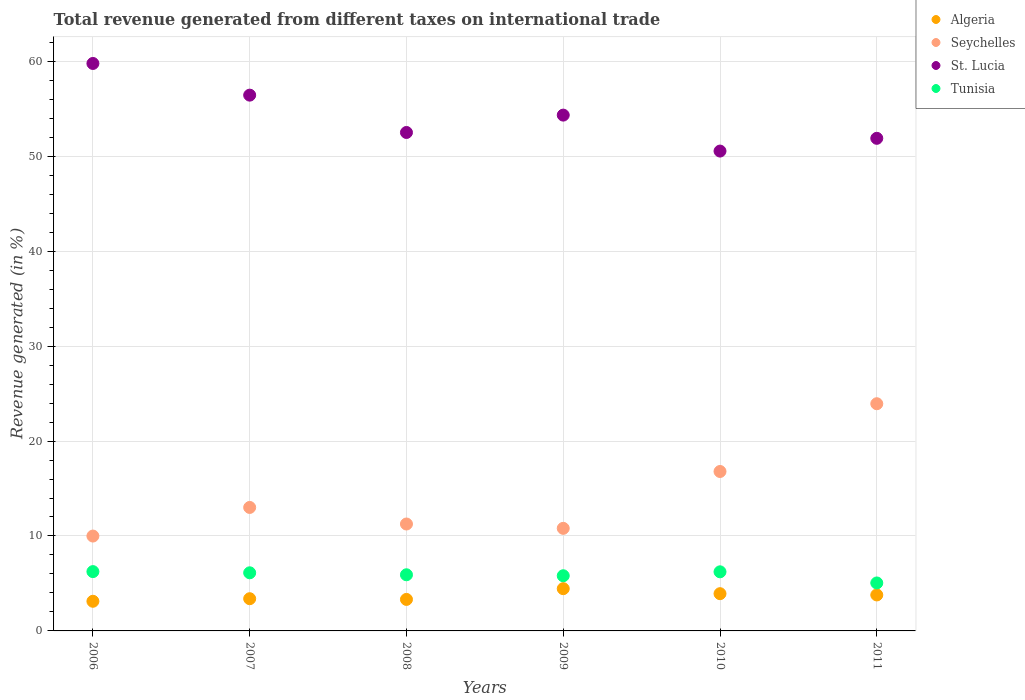Is the number of dotlines equal to the number of legend labels?
Your answer should be very brief. Yes. What is the total revenue generated in Tunisia in 2011?
Make the answer very short. 5.05. Across all years, what is the maximum total revenue generated in Tunisia?
Make the answer very short. 6.25. Across all years, what is the minimum total revenue generated in Tunisia?
Give a very brief answer. 5.05. In which year was the total revenue generated in Seychelles minimum?
Your answer should be compact. 2006. What is the total total revenue generated in St. Lucia in the graph?
Ensure brevity in your answer.  325.46. What is the difference between the total revenue generated in Seychelles in 2007 and that in 2011?
Make the answer very short. -10.92. What is the difference between the total revenue generated in Seychelles in 2007 and the total revenue generated in Algeria in 2010?
Your answer should be very brief. 9.08. What is the average total revenue generated in Seychelles per year?
Keep it short and to the point. 14.3. In the year 2006, what is the difference between the total revenue generated in Tunisia and total revenue generated in St. Lucia?
Your response must be concise. -53.52. In how many years, is the total revenue generated in St. Lucia greater than 36 %?
Offer a very short reply. 6. What is the ratio of the total revenue generated in St. Lucia in 2009 to that in 2011?
Your answer should be very brief. 1.05. Is the total revenue generated in Seychelles in 2010 less than that in 2011?
Provide a succinct answer. Yes. Is the difference between the total revenue generated in Tunisia in 2008 and 2011 greater than the difference between the total revenue generated in St. Lucia in 2008 and 2011?
Your answer should be compact. Yes. What is the difference between the highest and the second highest total revenue generated in Seychelles?
Your answer should be compact. 7.14. What is the difference between the highest and the lowest total revenue generated in Tunisia?
Ensure brevity in your answer.  1.2. Is it the case that in every year, the sum of the total revenue generated in St. Lucia and total revenue generated in Tunisia  is greater than the sum of total revenue generated in Algeria and total revenue generated in Seychelles?
Give a very brief answer. No. Is it the case that in every year, the sum of the total revenue generated in St. Lucia and total revenue generated in Seychelles  is greater than the total revenue generated in Algeria?
Your answer should be compact. Yes. Is the total revenue generated in Algeria strictly greater than the total revenue generated in Seychelles over the years?
Provide a succinct answer. No. Is the total revenue generated in St. Lucia strictly less than the total revenue generated in Tunisia over the years?
Keep it short and to the point. No. How many dotlines are there?
Ensure brevity in your answer.  4. How many years are there in the graph?
Offer a terse response. 6. What is the difference between two consecutive major ticks on the Y-axis?
Provide a short and direct response. 10. Where does the legend appear in the graph?
Your answer should be compact. Top right. How many legend labels are there?
Offer a very short reply. 4. How are the legend labels stacked?
Your answer should be compact. Vertical. What is the title of the graph?
Keep it short and to the point. Total revenue generated from different taxes on international trade. What is the label or title of the Y-axis?
Keep it short and to the point. Revenue generated (in %). What is the Revenue generated (in %) of Algeria in 2006?
Provide a succinct answer. 3.12. What is the Revenue generated (in %) of Seychelles in 2006?
Offer a terse response. 9.99. What is the Revenue generated (in %) of St. Lucia in 2006?
Give a very brief answer. 59.77. What is the Revenue generated (in %) of Tunisia in 2006?
Make the answer very short. 6.25. What is the Revenue generated (in %) of Algeria in 2007?
Your answer should be very brief. 3.39. What is the Revenue generated (in %) of Seychelles in 2007?
Give a very brief answer. 13.01. What is the Revenue generated (in %) in St. Lucia in 2007?
Give a very brief answer. 56.43. What is the Revenue generated (in %) of Tunisia in 2007?
Your answer should be very brief. 6.12. What is the Revenue generated (in %) in Algeria in 2008?
Your answer should be very brief. 3.32. What is the Revenue generated (in %) of Seychelles in 2008?
Your response must be concise. 11.26. What is the Revenue generated (in %) of St. Lucia in 2008?
Make the answer very short. 52.5. What is the Revenue generated (in %) in Tunisia in 2008?
Provide a short and direct response. 5.91. What is the Revenue generated (in %) of Algeria in 2009?
Give a very brief answer. 4.45. What is the Revenue generated (in %) of Seychelles in 2009?
Offer a terse response. 10.8. What is the Revenue generated (in %) in St. Lucia in 2009?
Make the answer very short. 54.33. What is the Revenue generated (in %) in Tunisia in 2009?
Offer a very short reply. 5.81. What is the Revenue generated (in %) of Algeria in 2010?
Your answer should be very brief. 3.92. What is the Revenue generated (in %) in Seychelles in 2010?
Offer a very short reply. 16.79. What is the Revenue generated (in %) in St. Lucia in 2010?
Give a very brief answer. 50.54. What is the Revenue generated (in %) of Tunisia in 2010?
Provide a short and direct response. 6.23. What is the Revenue generated (in %) of Algeria in 2011?
Your response must be concise. 3.79. What is the Revenue generated (in %) of Seychelles in 2011?
Provide a succinct answer. 23.93. What is the Revenue generated (in %) of St. Lucia in 2011?
Provide a short and direct response. 51.89. What is the Revenue generated (in %) in Tunisia in 2011?
Provide a succinct answer. 5.05. Across all years, what is the maximum Revenue generated (in %) of Algeria?
Make the answer very short. 4.45. Across all years, what is the maximum Revenue generated (in %) of Seychelles?
Make the answer very short. 23.93. Across all years, what is the maximum Revenue generated (in %) of St. Lucia?
Provide a succinct answer. 59.77. Across all years, what is the maximum Revenue generated (in %) of Tunisia?
Provide a succinct answer. 6.25. Across all years, what is the minimum Revenue generated (in %) of Algeria?
Offer a very short reply. 3.12. Across all years, what is the minimum Revenue generated (in %) in Seychelles?
Your answer should be compact. 9.99. Across all years, what is the minimum Revenue generated (in %) in St. Lucia?
Keep it short and to the point. 50.54. Across all years, what is the minimum Revenue generated (in %) of Tunisia?
Provide a short and direct response. 5.05. What is the total Revenue generated (in %) of Algeria in the graph?
Keep it short and to the point. 22. What is the total Revenue generated (in %) in Seychelles in the graph?
Your answer should be very brief. 85.79. What is the total Revenue generated (in %) of St. Lucia in the graph?
Your response must be concise. 325.46. What is the total Revenue generated (in %) of Tunisia in the graph?
Your response must be concise. 35.37. What is the difference between the Revenue generated (in %) in Algeria in 2006 and that in 2007?
Keep it short and to the point. -0.27. What is the difference between the Revenue generated (in %) of Seychelles in 2006 and that in 2007?
Make the answer very short. -3.01. What is the difference between the Revenue generated (in %) of St. Lucia in 2006 and that in 2007?
Your answer should be very brief. 3.34. What is the difference between the Revenue generated (in %) of Tunisia in 2006 and that in 2007?
Ensure brevity in your answer.  0.13. What is the difference between the Revenue generated (in %) of Algeria in 2006 and that in 2008?
Provide a succinct answer. -0.2. What is the difference between the Revenue generated (in %) of Seychelles in 2006 and that in 2008?
Offer a terse response. -1.27. What is the difference between the Revenue generated (in %) in St. Lucia in 2006 and that in 2008?
Your answer should be compact. 7.27. What is the difference between the Revenue generated (in %) of Tunisia in 2006 and that in 2008?
Keep it short and to the point. 0.33. What is the difference between the Revenue generated (in %) in Algeria in 2006 and that in 2009?
Your answer should be very brief. -1.33. What is the difference between the Revenue generated (in %) in Seychelles in 2006 and that in 2009?
Your response must be concise. -0.81. What is the difference between the Revenue generated (in %) in St. Lucia in 2006 and that in 2009?
Ensure brevity in your answer.  5.44. What is the difference between the Revenue generated (in %) of Tunisia in 2006 and that in 2009?
Your answer should be compact. 0.44. What is the difference between the Revenue generated (in %) in Algeria in 2006 and that in 2010?
Give a very brief answer. -0.8. What is the difference between the Revenue generated (in %) in Seychelles in 2006 and that in 2010?
Offer a very short reply. -6.8. What is the difference between the Revenue generated (in %) in St. Lucia in 2006 and that in 2010?
Ensure brevity in your answer.  9.23. What is the difference between the Revenue generated (in %) of Tunisia in 2006 and that in 2010?
Provide a succinct answer. 0.02. What is the difference between the Revenue generated (in %) in Algeria in 2006 and that in 2011?
Your answer should be compact. -0.67. What is the difference between the Revenue generated (in %) in Seychelles in 2006 and that in 2011?
Ensure brevity in your answer.  -13.94. What is the difference between the Revenue generated (in %) of St. Lucia in 2006 and that in 2011?
Provide a succinct answer. 7.88. What is the difference between the Revenue generated (in %) of Tunisia in 2006 and that in 2011?
Provide a succinct answer. 1.2. What is the difference between the Revenue generated (in %) of Algeria in 2007 and that in 2008?
Offer a very short reply. 0.07. What is the difference between the Revenue generated (in %) of Seychelles in 2007 and that in 2008?
Keep it short and to the point. 1.74. What is the difference between the Revenue generated (in %) in St. Lucia in 2007 and that in 2008?
Keep it short and to the point. 3.93. What is the difference between the Revenue generated (in %) in Tunisia in 2007 and that in 2008?
Offer a very short reply. 0.21. What is the difference between the Revenue generated (in %) of Algeria in 2007 and that in 2009?
Your answer should be compact. -1.06. What is the difference between the Revenue generated (in %) in Seychelles in 2007 and that in 2009?
Your response must be concise. 2.2. What is the difference between the Revenue generated (in %) of St. Lucia in 2007 and that in 2009?
Your answer should be very brief. 2.1. What is the difference between the Revenue generated (in %) in Tunisia in 2007 and that in 2009?
Offer a terse response. 0.31. What is the difference between the Revenue generated (in %) of Algeria in 2007 and that in 2010?
Offer a terse response. -0.53. What is the difference between the Revenue generated (in %) of Seychelles in 2007 and that in 2010?
Offer a very short reply. -3.79. What is the difference between the Revenue generated (in %) of St. Lucia in 2007 and that in 2010?
Ensure brevity in your answer.  5.89. What is the difference between the Revenue generated (in %) in Tunisia in 2007 and that in 2010?
Make the answer very short. -0.1. What is the difference between the Revenue generated (in %) in Algeria in 2007 and that in 2011?
Provide a succinct answer. -0.4. What is the difference between the Revenue generated (in %) of Seychelles in 2007 and that in 2011?
Ensure brevity in your answer.  -10.92. What is the difference between the Revenue generated (in %) of St. Lucia in 2007 and that in 2011?
Offer a terse response. 4.55. What is the difference between the Revenue generated (in %) of Tunisia in 2007 and that in 2011?
Offer a very short reply. 1.07. What is the difference between the Revenue generated (in %) of Algeria in 2008 and that in 2009?
Keep it short and to the point. -1.13. What is the difference between the Revenue generated (in %) in Seychelles in 2008 and that in 2009?
Give a very brief answer. 0.46. What is the difference between the Revenue generated (in %) of St. Lucia in 2008 and that in 2009?
Offer a very short reply. -1.83. What is the difference between the Revenue generated (in %) in Tunisia in 2008 and that in 2009?
Keep it short and to the point. 0.1. What is the difference between the Revenue generated (in %) in Algeria in 2008 and that in 2010?
Provide a succinct answer. -0.6. What is the difference between the Revenue generated (in %) in Seychelles in 2008 and that in 2010?
Ensure brevity in your answer.  -5.53. What is the difference between the Revenue generated (in %) of St. Lucia in 2008 and that in 2010?
Offer a very short reply. 1.96. What is the difference between the Revenue generated (in %) in Tunisia in 2008 and that in 2010?
Ensure brevity in your answer.  -0.31. What is the difference between the Revenue generated (in %) of Algeria in 2008 and that in 2011?
Provide a short and direct response. -0.47. What is the difference between the Revenue generated (in %) in Seychelles in 2008 and that in 2011?
Give a very brief answer. -12.67. What is the difference between the Revenue generated (in %) of St. Lucia in 2008 and that in 2011?
Provide a succinct answer. 0.61. What is the difference between the Revenue generated (in %) in Tunisia in 2008 and that in 2011?
Your response must be concise. 0.86. What is the difference between the Revenue generated (in %) of Algeria in 2009 and that in 2010?
Give a very brief answer. 0.53. What is the difference between the Revenue generated (in %) of Seychelles in 2009 and that in 2010?
Offer a terse response. -5.99. What is the difference between the Revenue generated (in %) of St. Lucia in 2009 and that in 2010?
Ensure brevity in your answer.  3.79. What is the difference between the Revenue generated (in %) of Tunisia in 2009 and that in 2010?
Give a very brief answer. -0.41. What is the difference between the Revenue generated (in %) of Algeria in 2009 and that in 2011?
Your answer should be very brief. 0.66. What is the difference between the Revenue generated (in %) of Seychelles in 2009 and that in 2011?
Make the answer very short. -13.13. What is the difference between the Revenue generated (in %) in St. Lucia in 2009 and that in 2011?
Your response must be concise. 2.44. What is the difference between the Revenue generated (in %) of Tunisia in 2009 and that in 2011?
Offer a terse response. 0.76. What is the difference between the Revenue generated (in %) of Algeria in 2010 and that in 2011?
Offer a very short reply. 0.13. What is the difference between the Revenue generated (in %) of Seychelles in 2010 and that in 2011?
Ensure brevity in your answer.  -7.14. What is the difference between the Revenue generated (in %) of St. Lucia in 2010 and that in 2011?
Keep it short and to the point. -1.34. What is the difference between the Revenue generated (in %) in Tunisia in 2010 and that in 2011?
Your answer should be very brief. 1.17. What is the difference between the Revenue generated (in %) in Algeria in 2006 and the Revenue generated (in %) in Seychelles in 2007?
Your answer should be very brief. -9.88. What is the difference between the Revenue generated (in %) of Algeria in 2006 and the Revenue generated (in %) of St. Lucia in 2007?
Ensure brevity in your answer.  -53.31. What is the difference between the Revenue generated (in %) in Algeria in 2006 and the Revenue generated (in %) in Tunisia in 2007?
Your response must be concise. -3. What is the difference between the Revenue generated (in %) of Seychelles in 2006 and the Revenue generated (in %) of St. Lucia in 2007?
Offer a very short reply. -46.44. What is the difference between the Revenue generated (in %) in Seychelles in 2006 and the Revenue generated (in %) in Tunisia in 2007?
Provide a succinct answer. 3.87. What is the difference between the Revenue generated (in %) in St. Lucia in 2006 and the Revenue generated (in %) in Tunisia in 2007?
Ensure brevity in your answer.  53.65. What is the difference between the Revenue generated (in %) of Algeria in 2006 and the Revenue generated (in %) of Seychelles in 2008?
Your answer should be very brief. -8.14. What is the difference between the Revenue generated (in %) in Algeria in 2006 and the Revenue generated (in %) in St. Lucia in 2008?
Keep it short and to the point. -49.38. What is the difference between the Revenue generated (in %) of Algeria in 2006 and the Revenue generated (in %) of Tunisia in 2008?
Make the answer very short. -2.79. What is the difference between the Revenue generated (in %) of Seychelles in 2006 and the Revenue generated (in %) of St. Lucia in 2008?
Provide a succinct answer. -42.51. What is the difference between the Revenue generated (in %) in Seychelles in 2006 and the Revenue generated (in %) in Tunisia in 2008?
Ensure brevity in your answer.  4.08. What is the difference between the Revenue generated (in %) of St. Lucia in 2006 and the Revenue generated (in %) of Tunisia in 2008?
Offer a very short reply. 53.86. What is the difference between the Revenue generated (in %) of Algeria in 2006 and the Revenue generated (in %) of Seychelles in 2009?
Your answer should be compact. -7.68. What is the difference between the Revenue generated (in %) of Algeria in 2006 and the Revenue generated (in %) of St. Lucia in 2009?
Offer a terse response. -51.21. What is the difference between the Revenue generated (in %) in Algeria in 2006 and the Revenue generated (in %) in Tunisia in 2009?
Provide a short and direct response. -2.69. What is the difference between the Revenue generated (in %) in Seychelles in 2006 and the Revenue generated (in %) in St. Lucia in 2009?
Your response must be concise. -44.34. What is the difference between the Revenue generated (in %) of Seychelles in 2006 and the Revenue generated (in %) of Tunisia in 2009?
Give a very brief answer. 4.18. What is the difference between the Revenue generated (in %) in St. Lucia in 2006 and the Revenue generated (in %) in Tunisia in 2009?
Your answer should be compact. 53.96. What is the difference between the Revenue generated (in %) in Algeria in 2006 and the Revenue generated (in %) in Seychelles in 2010?
Make the answer very short. -13.67. What is the difference between the Revenue generated (in %) of Algeria in 2006 and the Revenue generated (in %) of St. Lucia in 2010?
Provide a succinct answer. -47.42. What is the difference between the Revenue generated (in %) of Algeria in 2006 and the Revenue generated (in %) of Tunisia in 2010?
Give a very brief answer. -3.1. What is the difference between the Revenue generated (in %) of Seychelles in 2006 and the Revenue generated (in %) of St. Lucia in 2010?
Ensure brevity in your answer.  -40.55. What is the difference between the Revenue generated (in %) in Seychelles in 2006 and the Revenue generated (in %) in Tunisia in 2010?
Your answer should be compact. 3.77. What is the difference between the Revenue generated (in %) in St. Lucia in 2006 and the Revenue generated (in %) in Tunisia in 2010?
Your answer should be very brief. 53.54. What is the difference between the Revenue generated (in %) in Algeria in 2006 and the Revenue generated (in %) in Seychelles in 2011?
Offer a very short reply. -20.81. What is the difference between the Revenue generated (in %) of Algeria in 2006 and the Revenue generated (in %) of St. Lucia in 2011?
Your answer should be very brief. -48.76. What is the difference between the Revenue generated (in %) in Algeria in 2006 and the Revenue generated (in %) in Tunisia in 2011?
Your answer should be compact. -1.93. What is the difference between the Revenue generated (in %) in Seychelles in 2006 and the Revenue generated (in %) in St. Lucia in 2011?
Your response must be concise. -41.89. What is the difference between the Revenue generated (in %) in Seychelles in 2006 and the Revenue generated (in %) in Tunisia in 2011?
Your answer should be compact. 4.94. What is the difference between the Revenue generated (in %) of St. Lucia in 2006 and the Revenue generated (in %) of Tunisia in 2011?
Provide a succinct answer. 54.72. What is the difference between the Revenue generated (in %) in Algeria in 2007 and the Revenue generated (in %) in Seychelles in 2008?
Provide a short and direct response. -7.87. What is the difference between the Revenue generated (in %) of Algeria in 2007 and the Revenue generated (in %) of St. Lucia in 2008?
Offer a terse response. -49.11. What is the difference between the Revenue generated (in %) in Algeria in 2007 and the Revenue generated (in %) in Tunisia in 2008?
Offer a very short reply. -2.52. What is the difference between the Revenue generated (in %) of Seychelles in 2007 and the Revenue generated (in %) of St. Lucia in 2008?
Provide a short and direct response. -39.49. What is the difference between the Revenue generated (in %) of Seychelles in 2007 and the Revenue generated (in %) of Tunisia in 2008?
Keep it short and to the point. 7.09. What is the difference between the Revenue generated (in %) in St. Lucia in 2007 and the Revenue generated (in %) in Tunisia in 2008?
Your answer should be compact. 50.52. What is the difference between the Revenue generated (in %) in Algeria in 2007 and the Revenue generated (in %) in Seychelles in 2009?
Your response must be concise. -7.41. What is the difference between the Revenue generated (in %) of Algeria in 2007 and the Revenue generated (in %) of St. Lucia in 2009?
Ensure brevity in your answer.  -50.94. What is the difference between the Revenue generated (in %) in Algeria in 2007 and the Revenue generated (in %) in Tunisia in 2009?
Your response must be concise. -2.42. What is the difference between the Revenue generated (in %) of Seychelles in 2007 and the Revenue generated (in %) of St. Lucia in 2009?
Keep it short and to the point. -41.32. What is the difference between the Revenue generated (in %) of Seychelles in 2007 and the Revenue generated (in %) of Tunisia in 2009?
Provide a succinct answer. 7.19. What is the difference between the Revenue generated (in %) of St. Lucia in 2007 and the Revenue generated (in %) of Tunisia in 2009?
Keep it short and to the point. 50.62. What is the difference between the Revenue generated (in %) of Algeria in 2007 and the Revenue generated (in %) of Seychelles in 2010?
Your answer should be compact. -13.4. What is the difference between the Revenue generated (in %) in Algeria in 2007 and the Revenue generated (in %) in St. Lucia in 2010?
Your answer should be very brief. -47.15. What is the difference between the Revenue generated (in %) in Algeria in 2007 and the Revenue generated (in %) in Tunisia in 2010?
Offer a terse response. -2.83. What is the difference between the Revenue generated (in %) of Seychelles in 2007 and the Revenue generated (in %) of St. Lucia in 2010?
Provide a short and direct response. -37.54. What is the difference between the Revenue generated (in %) in Seychelles in 2007 and the Revenue generated (in %) in Tunisia in 2010?
Your answer should be compact. 6.78. What is the difference between the Revenue generated (in %) in St. Lucia in 2007 and the Revenue generated (in %) in Tunisia in 2010?
Your response must be concise. 50.21. What is the difference between the Revenue generated (in %) of Algeria in 2007 and the Revenue generated (in %) of Seychelles in 2011?
Give a very brief answer. -20.54. What is the difference between the Revenue generated (in %) of Algeria in 2007 and the Revenue generated (in %) of St. Lucia in 2011?
Offer a terse response. -48.49. What is the difference between the Revenue generated (in %) of Algeria in 2007 and the Revenue generated (in %) of Tunisia in 2011?
Offer a terse response. -1.66. What is the difference between the Revenue generated (in %) in Seychelles in 2007 and the Revenue generated (in %) in St. Lucia in 2011?
Provide a succinct answer. -38.88. What is the difference between the Revenue generated (in %) in Seychelles in 2007 and the Revenue generated (in %) in Tunisia in 2011?
Your answer should be compact. 7.95. What is the difference between the Revenue generated (in %) in St. Lucia in 2007 and the Revenue generated (in %) in Tunisia in 2011?
Offer a terse response. 51.38. What is the difference between the Revenue generated (in %) of Algeria in 2008 and the Revenue generated (in %) of Seychelles in 2009?
Provide a succinct answer. -7.49. What is the difference between the Revenue generated (in %) of Algeria in 2008 and the Revenue generated (in %) of St. Lucia in 2009?
Your answer should be compact. -51.01. What is the difference between the Revenue generated (in %) of Algeria in 2008 and the Revenue generated (in %) of Tunisia in 2009?
Make the answer very short. -2.49. What is the difference between the Revenue generated (in %) of Seychelles in 2008 and the Revenue generated (in %) of St. Lucia in 2009?
Provide a short and direct response. -43.07. What is the difference between the Revenue generated (in %) in Seychelles in 2008 and the Revenue generated (in %) in Tunisia in 2009?
Offer a terse response. 5.45. What is the difference between the Revenue generated (in %) of St. Lucia in 2008 and the Revenue generated (in %) of Tunisia in 2009?
Keep it short and to the point. 46.69. What is the difference between the Revenue generated (in %) of Algeria in 2008 and the Revenue generated (in %) of Seychelles in 2010?
Provide a short and direct response. -13.47. What is the difference between the Revenue generated (in %) in Algeria in 2008 and the Revenue generated (in %) in St. Lucia in 2010?
Provide a succinct answer. -47.22. What is the difference between the Revenue generated (in %) of Algeria in 2008 and the Revenue generated (in %) of Tunisia in 2010?
Offer a terse response. -2.91. What is the difference between the Revenue generated (in %) in Seychelles in 2008 and the Revenue generated (in %) in St. Lucia in 2010?
Your response must be concise. -39.28. What is the difference between the Revenue generated (in %) in Seychelles in 2008 and the Revenue generated (in %) in Tunisia in 2010?
Ensure brevity in your answer.  5.04. What is the difference between the Revenue generated (in %) of St. Lucia in 2008 and the Revenue generated (in %) of Tunisia in 2010?
Offer a terse response. 46.27. What is the difference between the Revenue generated (in %) in Algeria in 2008 and the Revenue generated (in %) in Seychelles in 2011?
Offer a terse response. -20.61. What is the difference between the Revenue generated (in %) in Algeria in 2008 and the Revenue generated (in %) in St. Lucia in 2011?
Offer a terse response. -48.57. What is the difference between the Revenue generated (in %) in Algeria in 2008 and the Revenue generated (in %) in Tunisia in 2011?
Offer a terse response. -1.73. What is the difference between the Revenue generated (in %) in Seychelles in 2008 and the Revenue generated (in %) in St. Lucia in 2011?
Your answer should be very brief. -40.62. What is the difference between the Revenue generated (in %) of Seychelles in 2008 and the Revenue generated (in %) of Tunisia in 2011?
Your answer should be very brief. 6.21. What is the difference between the Revenue generated (in %) of St. Lucia in 2008 and the Revenue generated (in %) of Tunisia in 2011?
Offer a very short reply. 47.45. What is the difference between the Revenue generated (in %) of Algeria in 2009 and the Revenue generated (in %) of Seychelles in 2010?
Offer a terse response. -12.34. What is the difference between the Revenue generated (in %) of Algeria in 2009 and the Revenue generated (in %) of St. Lucia in 2010?
Your answer should be compact. -46.09. What is the difference between the Revenue generated (in %) in Algeria in 2009 and the Revenue generated (in %) in Tunisia in 2010?
Keep it short and to the point. -1.77. What is the difference between the Revenue generated (in %) in Seychelles in 2009 and the Revenue generated (in %) in St. Lucia in 2010?
Keep it short and to the point. -39.74. What is the difference between the Revenue generated (in %) of Seychelles in 2009 and the Revenue generated (in %) of Tunisia in 2010?
Offer a very short reply. 4.58. What is the difference between the Revenue generated (in %) of St. Lucia in 2009 and the Revenue generated (in %) of Tunisia in 2010?
Make the answer very short. 48.1. What is the difference between the Revenue generated (in %) in Algeria in 2009 and the Revenue generated (in %) in Seychelles in 2011?
Provide a short and direct response. -19.48. What is the difference between the Revenue generated (in %) in Algeria in 2009 and the Revenue generated (in %) in St. Lucia in 2011?
Make the answer very short. -47.44. What is the difference between the Revenue generated (in %) in Algeria in 2009 and the Revenue generated (in %) in Tunisia in 2011?
Give a very brief answer. -0.6. What is the difference between the Revenue generated (in %) in Seychelles in 2009 and the Revenue generated (in %) in St. Lucia in 2011?
Ensure brevity in your answer.  -41.08. What is the difference between the Revenue generated (in %) in Seychelles in 2009 and the Revenue generated (in %) in Tunisia in 2011?
Your answer should be compact. 5.75. What is the difference between the Revenue generated (in %) of St. Lucia in 2009 and the Revenue generated (in %) of Tunisia in 2011?
Your response must be concise. 49.28. What is the difference between the Revenue generated (in %) of Algeria in 2010 and the Revenue generated (in %) of Seychelles in 2011?
Your answer should be very brief. -20.01. What is the difference between the Revenue generated (in %) of Algeria in 2010 and the Revenue generated (in %) of St. Lucia in 2011?
Provide a succinct answer. -47.96. What is the difference between the Revenue generated (in %) of Algeria in 2010 and the Revenue generated (in %) of Tunisia in 2011?
Your answer should be compact. -1.13. What is the difference between the Revenue generated (in %) in Seychelles in 2010 and the Revenue generated (in %) in St. Lucia in 2011?
Provide a succinct answer. -35.09. What is the difference between the Revenue generated (in %) of Seychelles in 2010 and the Revenue generated (in %) of Tunisia in 2011?
Give a very brief answer. 11.74. What is the difference between the Revenue generated (in %) in St. Lucia in 2010 and the Revenue generated (in %) in Tunisia in 2011?
Give a very brief answer. 45.49. What is the average Revenue generated (in %) in Algeria per year?
Make the answer very short. 3.67. What is the average Revenue generated (in %) in Seychelles per year?
Your response must be concise. 14.3. What is the average Revenue generated (in %) in St. Lucia per year?
Provide a short and direct response. 54.24. What is the average Revenue generated (in %) of Tunisia per year?
Offer a terse response. 5.9. In the year 2006, what is the difference between the Revenue generated (in %) in Algeria and Revenue generated (in %) in Seychelles?
Offer a very short reply. -6.87. In the year 2006, what is the difference between the Revenue generated (in %) in Algeria and Revenue generated (in %) in St. Lucia?
Make the answer very short. -56.65. In the year 2006, what is the difference between the Revenue generated (in %) in Algeria and Revenue generated (in %) in Tunisia?
Offer a very short reply. -3.13. In the year 2006, what is the difference between the Revenue generated (in %) in Seychelles and Revenue generated (in %) in St. Lucia?
Keep it short and to the point. -49.78. In the year 2006, what is the difference between the Revenue generated (in %) in Seychelles and Revenue generated (in %) in Tunisia?
Your answer should be very brief. 3.75. In the year 2006, what is the difference between the Revenue generated (in %) of St. Lucia and Revenue generated (in %) of Tunisia?
Make the answer very short. 53.52. In the year 2007, what is the difference between the Revenue generated (in %) in Algeria and Revenue generated (in %) in Seychelles?
Offer a terse response. -9.61. In the year 2007, what is the difference between the Revenue generated (in %) in Algeria and Revenue generated (in %) in St. Lucia?
Your response must be concise. -53.04. In the year 2007, what is the difference between the Revenue generated (in %) of Algeria and Revenue generated (in %) of Tunisia?
Make the answer very short. -2.73. In the year 2007, what is the difference between the Revenue generated (in %) in Seychelles and Revenue generated (in %) in St. Lucia?
Provide a succinct answer. -43.43. In the year 2007, what is the difference between the Revenue generated (in %) of Seychelles and Revenue generated (in %) of Tunisia?
Your response must be concise. 6.88. In the year 2007, what is the difference between the Revenue generated (in %) of St. Lucia and Revenue generated (in %) of Tunisia?
Your response must be concise. 50.31. In the year 2008, what is the difference between the Revenue generated (in %) in Algeria and Revenue generated (in %) in Seychelles?
Make the answer very short. -7.94. In the year 2008, what is the difference between the Revenue generated (in %) in Algeria and Revenue generated (in %) in St. Lucia?
Your answer should be compact. -49.18. In the year 2008, what is the difference between the Revenue generated (in %) in Algeria and Revenue generated (in %) in Tunisia?
Offer a terse response. -2.59. In the year 2008, what is the difference between the Revenue generated (in %) in Seychelles and Revenue generated (in %) in St. Lucia?
Give a very brief answer. -41.24. In the year 2008, what is the difference between the Revenue generated (in %) in Seychelles and Revenue generated (in %) in Tunisia?
Your answer should be very brief. 5.35. In the year 2008, what is the difference between the Revenue generated (in %) in St. Lucia and Revenue generated (in %) in Tunisia?
Ensure brevity in your answer.  46.59. In the year 2009, what is the difference between the Revenue generated (in %) in Algeria and Revenue generated (in %) in Seychelles?
Your answer should be compact. -6.35. In the year 2009, what is the difference between the Revenue generated (in %) in Algeria and Revenue generated (in %) in St. Lucia?
Make the answer very short. -49.88. In the year 2009, what is the difference between the Revenue generated (in %) in Algeria and Revenue generated (in %) in Tunisia?
Provide a short and direct response. -1.36. In the year 2009, what is the difference between the Revenue generated (in %) of Seychelles and Revenue generated (in %) of St. Lucia?
Your answer should be very brief. -43.53. In the year 2009, what is the difference between the Revenue generated (in %) of Seychelles and Revenue generated (in %) of Tunisia?
Offer a very short reply. 4.99. In the year 2009, what is the difference between the Revenue generated (in %) in St. Lucia and Revenue generated (in %) in Tunisia?
Offer a terse response. 48.52. In the year 2010, what is the difference between the Revenue generated (in %) in Algeria and Revenue generated (in %) in Seychelles?
Provide a short and direct response. -12.87. In the year 2010, what is the difference between the Revenue generated (in %) in Algeria and Revenue generated (in %) in St. Lucia?
Ensure brevity in your answer.  -46.62. In the year 2010, what is the difference between the Revenue generated (in %) in Algeria and Revenue generated (in %) in Tunisia?
Your response must be concise. -2.3. In the year 2010, what is the difference between the Revenue generated (in %) of Seychelles and Revenue generated (in %) of St. Lucia?
Make the answer very short. -33.75. In the year 2010, what is the difference between the Revenue generated (in %) of Seychelles and Revenue generated (in %) of Tunisia?
Provide a succinct answer. 10.57. In the year 2010, what is the difference between the Revenue generated (in %) of St. Lucia and Revenue generated (in %) of Tunisia?
Make the answer very short. 44.32. In the year 2011, what is the difference between the Revenue generated (in %) of Algeria and Revenue generated (in %) of Seychelles?
Keep it short and to the point. -20.14. In the year 2011, what is the difference between the Revenue generated (in %) of Algeria and Revenue generated (in %) of St. Lucia?
Provide a short and direct response. -48.1. In the year 2011, what is the difference between the Revenue generated (in %) of Algeria and Revenue generated (in %) of Tunisia?
Provide a short and direct response. -1.26. In the year 2011, what is the difference between the Revenue generated (in %) of Seychelles and Revenue generated (in %) of St. Lucia?
Provide a succinct answer. -27.96. In the year 2011, what is the difference between the Revenue generated (in %) in Seychelles and Revenue generated (in %) in Tunisia?
Give a very brief answer. 18.88. In the year 2011, what is the difference between the Revenue generated (in %) of St. Lucia and Revenue generated (in %) of Tunisia?
Your answer should be very brief. 46.83. What is the ratio of the Revenue generated (in %) of Algeria in 2006 to that in 2007?
Ensure brevity in your answer.  0.92. What is the ratio of the Revenue generated (in %) in Seychelles in 2006 to that in 2007?
Provide a succinct answer. 0.77. What is the ratio of the Revenue generated (in %) of St. Lucia in 2006 to that in 2007?
Ensure brevity in your answer.  1.06. What is the ratio of the Revenue generated (in %) in Tunisia in 2006 to that in 2007?
Make the answer very short. 1.02. What is the ratio of the Revenue generated (in %) in Algeria in 2006 to that in 2008?
Your response must be concise. 0.94. What is the ratio of the Revenue generated (in %) of Seychelles in 2006 to that in 2008?
Keep it short and to the point. 0.89. What is the ratio of the Revenue generated (in %) of St. Lucia in 2006 to that in 2008?
Give a very brief answer. 1.14. What is the ratio of the Revenue generated (in %) of Tunisia in 2006 to that in 2008?
Your response must be concise. 1.06. What is the ratio of the Revenue generated (in %) in Algeria in 2006 to that in 2009?
Give a very brief answer. 0.7. What is the ratio of the Revenue generated (in %) in Seychelles in 2006 to that in 2009?
Give a very brief answer. 0.92. What is the ratio of the Revenue generated (in %) of St. Lucia in 2006 to that in 2009?
Offer a terse response. 1.1. What is the ratio of the Revenue generated (in %) in Tunisia in 2006 to that in 2009?
Offer a very short reply. 1.08. What is the ratio of the Revenue generated (in %) of Algeria in 2006 to that in 2010?
Offer a very short reply. 0.8. What is the ratio of the Revenue generated (in %) in Seychelles in 2006 to that in 2010?
Your answer should be compact. 0.6. What is the ratio of the Revenue generated (in %) of St. Lucia in 2006 to that in 2010?
Offer a very short reply. 1.18. What is the ratio of the Revenue generated (in %) of Algeria in 2006 to that in 2011?
Offer a terse response. 0.82. What is the ratio of the Revenue generated (in %) of Seychelles in 2006 to that in 2011?
Your answer should be compact. 0.42. What is the ratio of the Revenue generated (in %) of St. Lucia in 2006 to that in 2011?
Your answer should be compact. 1.15. What is the ratio of the Revenue generated (in %) of Tunisia in 2006 to that in 2011?
Keep it short and to the point. 1.24. What is the ratio of the Revenue generated (in %) of Algeria in 2007 to that in 2008?
Give a very brief answer. 1.02. What is the ratio of the Revenue generated (in %) in Seychelles in 2007 to that in 2008?
Your answer should be very brief. 1.15. What is the ratio of the Revenue generated (in %) in St. Lucia in 2007 to that in 2008?
Give a very brief answer. 1.07. What is the ratio of the Revenue generated (in %) of Tunisia in 2007 to that in 2008?
Offer a terse response. 1.04. What is the ratio of the Revenue generated (in %) of Algeria in 2007 to that in 2009?
Your response must be concise. 0.76. What is the ratio of the Revenue generated (in %) of Seychelles in 2007 to that in 2009?
Give a very brief answer. 1.2. What is the ratio of the Revenue generated (in %) in St. Lucia in 2007 to that in 2009?
Offer a very short reply. 1.04. What is the ratio of the Revenue generated (in %) of Tunisia in 2007 to that in 2009?
Provide a succinct answer. 1.05. What is the ratio of the Revenue generated (in %) of Algeria in 2007 to that in 2010?
Your answer should be very brief. 0.86. What is the ratio of the Revenue generated (in %) in Seychelles in 2007 to that in 2010?
Your answer should be very brief. 0.77. What is the ratio of the Revenue generated (in %) of St. Lucia in 2007 to that in 2010?
Offer a terse response. 1.12. What is the ratio of the Revenue generated (in %) of Tunisia in 2007 to that in 2010?
Provide a short and direct response. 0.98. What is the ratio of the Revenue generated (in %) of Algeria in 2007 to that in 2011?
Your answer should be very brief. 0.9. What is the ratio of the Revenue generated (in %) in Seychelles in 2007 to that in 2011?
Ensure brevity in your answer.  0.54. What is the ratio of the Revenue generated (in %) in St. Lucia in 2007 to that in 2011?
Offer a terse response. 1.09. What is the ratio of the Revenue generated (in %) in Tunisia in 2007 to that in 2011?
Offer a terse response. 1.21. What is the ratio of the Revenue generated (in %) of Algeria in 2008 to that in 2009?
Provide a short and direct response. 0.75. What is the ratio of the Revenue generated (in %) of Seychelles in 2008 to that in 2009?
Ensure brevity in your answer.  1.04. What is the ratio of the Revenue generated (in %) in St. Lucia in 2008 to that in 2009?
Keep it short and to the point. 0.97. What is the ratio of the Revenue generated (in %) of Tunisia in 2008 to that in 2009?
Give a very brief answer. 1.02. What is the ratio of the Revenue generated (in %) in Algeria in 2008 to that in 2010?
Offer a terse response. 0.85. What is the ratio of the Revenue generated (in %) in Seychelles in 2008 to that in 2010?
Provide a short and direct response. 0.67. What is the ratio of the Revenue generated (in %) of St. Lucia in 2008 to that in 2010?
Offer a terse response. 1.04. What is the ratio of the Revenue generated (in %) of Tunisia in 2008 to that in 2010?
Keep it short and to the point. 0.95. What is the ratio of the Revenue generated (in %) in Algeria in 2008 to that in 2011?
Provide a short and direct response. 0.88. What is the ratio of the Revenue generated (in %) of Seychelles in 2008 to that in 2011?
Keep it short and to the point. 0.47. What is the ratio of the Revenue generated (in %) in St. Lucia in 2008 to that in 2011?
Offer a very short reply. 1.01. What is the ratio of the Revenue generated (in %) in Tunisia in 2008 to that in 2011?
Your answer should be very brief. 1.17. What is the ratio of the Revenue generated (in %) in Algeria in 2009 to that in 2010?
Make the answer very short. 1.13. What is the ratio of the Revenue generated (in %) of Seychelles in 2009 to that in 2010?
Ensure brevity in your answer.  0.64. What is the ratio of the Revenue generated (in %) in St. Lucia in 2009 to that in 2010?
Your response must be concise. 1.07. What is the ratio of the Revenue generated (in %) of Tunisia in 2009 to that in 2010?
Ensure brevity in your answer.  0.93. What is the ratio of the Revenue generated (in %) of Algeria in 2009 to that in 2011?
Ensure brevity in your answer.  1.17. What is the ratio of the Revenue generated (in %) of Seychelles in 2009 to that in 2011?
Your answer should be compact. 0.45. What is the ratio of the Revenue generated (in %) of St. Lucia in 2009 to that in 2011?
Your response must be concise. 1.05. What is the ratio of the Revenue generated (in %) of Tunisia in 2009 to that in 2011?
Your answer should be very brief. 1.15. What is the ratio of the Revenue generated (in %) in Algeria in 2010 to that in 2011?
Offer a terse response. 1.04. What is the ratio of the Revenue generated (in %) in Seychelles in 2010 to that in 2011?
Offer a very short reply. 0.7. What is the ratio of the Revenue generated (in %) of St. Lucia in 2010 to that in 2011?
Give a very brief answer. 0.97. What is the ratio of the Revenue generated (in %) of Tunisia in 2010 to that in 2011?
Make the answer very short. 1.23. What is the difference between the highest and the second highest Revenue generated (in %) of Algeria?
Provide a short and direct response. 0.53. What is the difference between the highest and the second highest Revenue generated (in %) of Seychelles?
Make the answer very short. 7.14. What is the difference between the highest and the second highest Revenue generated (in %) of St. Lucia?
Offer a terse response. 3.34. What is the difference between the highest and the second highest Revenue generated (in %) in Tunisia?
Offer a very short reply. 0.02. What is the difference between the highest and the lowest Revenue generated (in %) of Algeria?
Give a very brief answer. 1.33. What is the difference between the highest and the lowest Revenue generated (in %) of Seychelles?
Your answer should be compact. 13.94. What is the difference between the highest and the lowest Revenue generated (in %) in St. Lucia?
Provide a short and direct response. 9.23. What is the difference between the highest and the lowest Revenue generated (in %) of Tunisia?
Your answer should be compact. 1.2. 